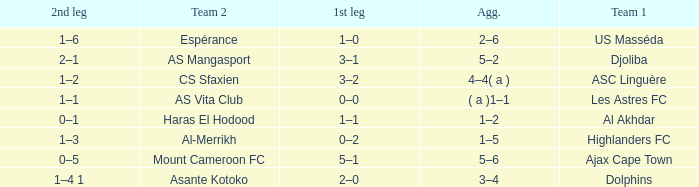What is the 2nd leg of team 1 Dolphins? 1–4 1. 